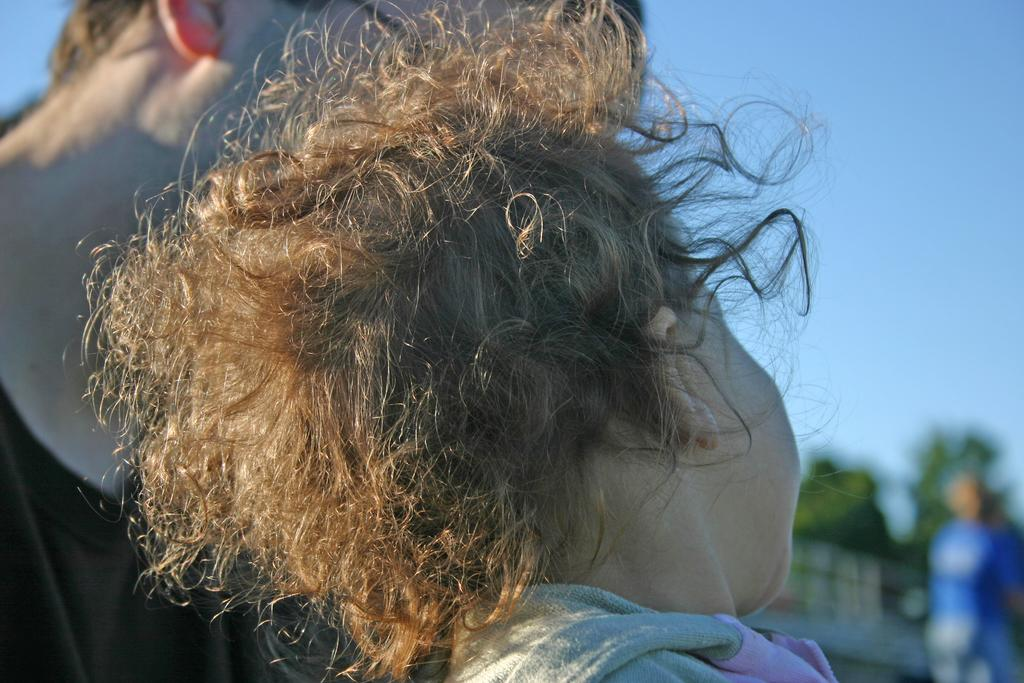How many people are in the image? There are persons in the image, but the exact number is not specified. What can be seen in the background of the image? The sky is visible in the image. What type of prose is being recited by the woman in the image? There is no woman or prose present in the image. How many flies can be seen buzzing around the persons in the image? There are no flies present in the image. 